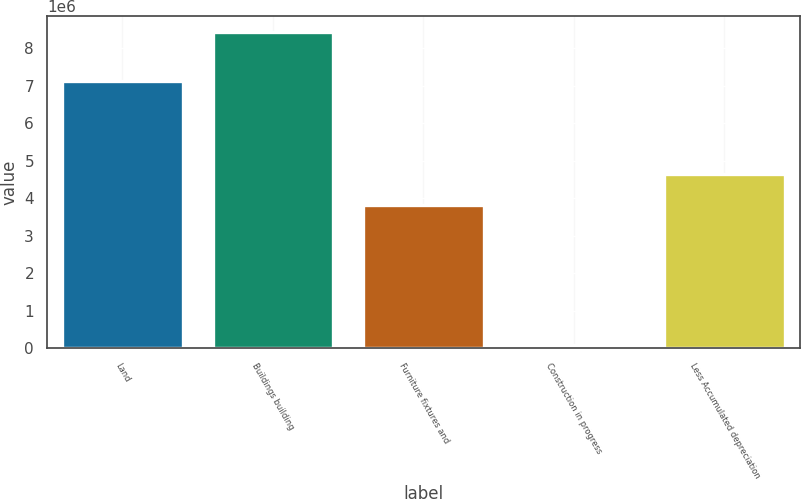<chart> <loc_0><loc_0><loc_500><loc_500><bar_chart><fcel>Land<fcel>Buildings building<fcel>Furniture fixtures and<fcel>Construction in progress<fcel>Less Accumulated depreciation<nl><fcel>7.121e+06<fcel>8.42877e+06<fcel>3.8146e+06<fcel>66902<fcel>4.65078e+06<nl></chart> 